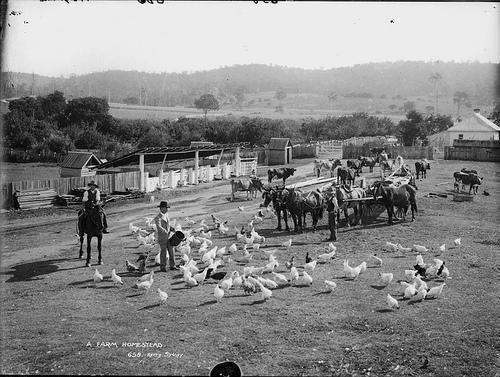How many different kinds of animals are shown in this picture?
Give a very brief answer. 3. 